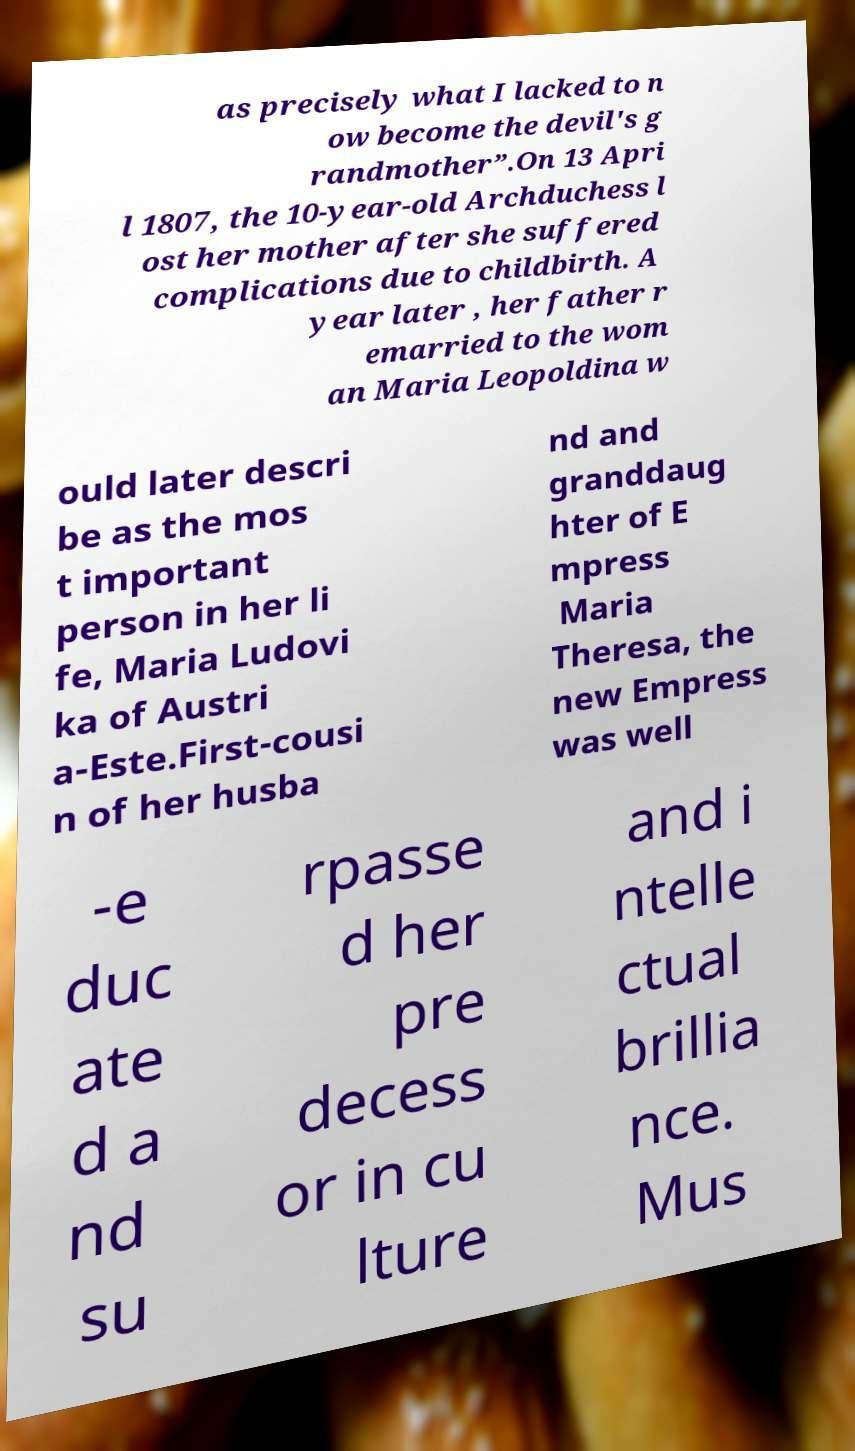There's text embedded in this image that I need extracted. Can you transcribe it verbatim? as precisely what I lacked to n ow become the devil's g randmother”.On 13 Apri l 1807, the 10-year-old Archduchess l ost her mother after she suffered complications due to childbirth. A year later , her father r emarried to the wom an Maria Leopoldina w ould later descri be as the mos t important person in her li fe, Maria Ludovi ka of Austri a-Este.First-cousi n of her husba nd and granddaug hter of E mpress Maria Theresa, the new Empress was well -e duc ate d a nd su rpasse d her pre decess or in cu lture and i ntelle ctual brillia nce. Mus 